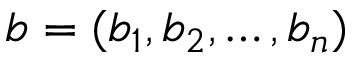<formula> <loc_0><loc_0><loc_500><loc_500>b = ( b _ { 1 } , b _ { 2 } , \dots , b _ { n } )</formula> 